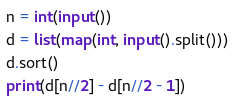<code> <loc_0><loc_0><loc_500><loc_500><_Python_>n = int(input())
d = list(map(int, input().split()))
d.sort()
print(d[n//2] - d[n//2 - 1])
</code> 